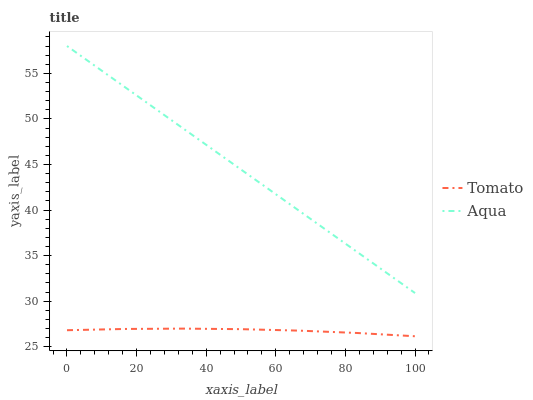Does Tomato have the minimum area under the curve?
Answer yes or no. Yes. Does Aqua have the maximum area under the curve?
Answer yes or no. Yes. Does Aqua have the minimum area under the curve?
Answer yes or no. No. Is Aqua the smoothest?
Answer yes or no. Yes. Is Tomato the roughest?
Answer yes or no. Yes. Is Aqua the roughest?
Answer yes or no. No. Does Tomato have the lowest value?
Answer yes or no. Yes. Does Aqua have the lowest value?
Answer yes or no. No. Does Aqua have the highest value?
Answer yes or no. Yes. Is Tomato less than Aqua?
Answer yes or no. Yes. Is Aqua greater than Tomato?
Answer yes or no. Yes. Does Tomato intersect Aqua?
Answer yes or no. No. 